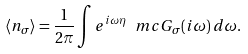<formula> <loc_0><loc_0><loc_500><loc_500>\left \langle n _ { \sigma } \right \rangle = \frac { 1 } { 2 \pi } \int e ^ { i \omega \eta } \ m c G _ { \sigma } ( i \omega ) \, d \omega .</formula> 